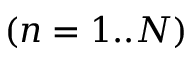Convert formula to latex. <formula><loc_0><loc_0><loc_500><loc_500>( n = 1 . . N )</formula> 